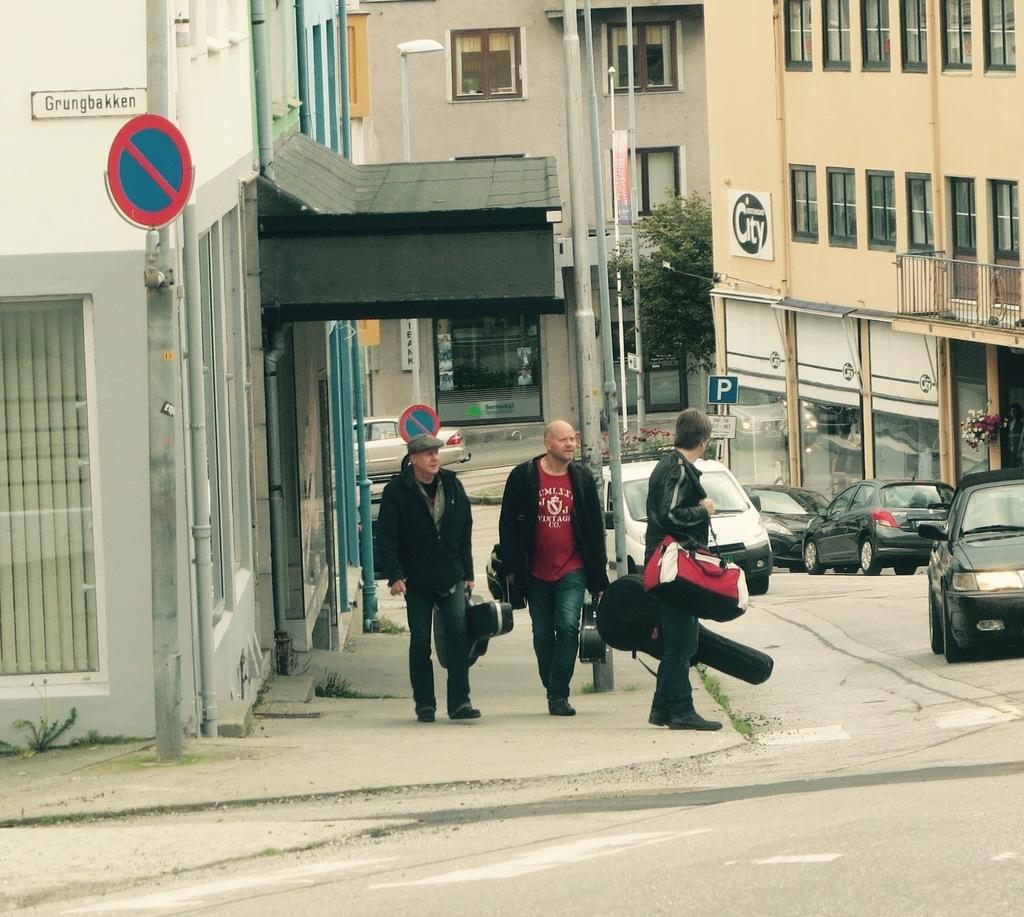<image>
Give a short and clear explanation of the subsequent image. Men standing in front of a buliding that says Grungbakken. 